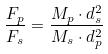<formula> <loc_0><loc_0><loc_500><loc_500>\frac { F _ { p } } { F _ { s } } = \frac { M _ { p } \cdot d _ { s } ^ { 2 } } { M _ { s } \cdot d _ { p } ^ { 2 } }</formula> 